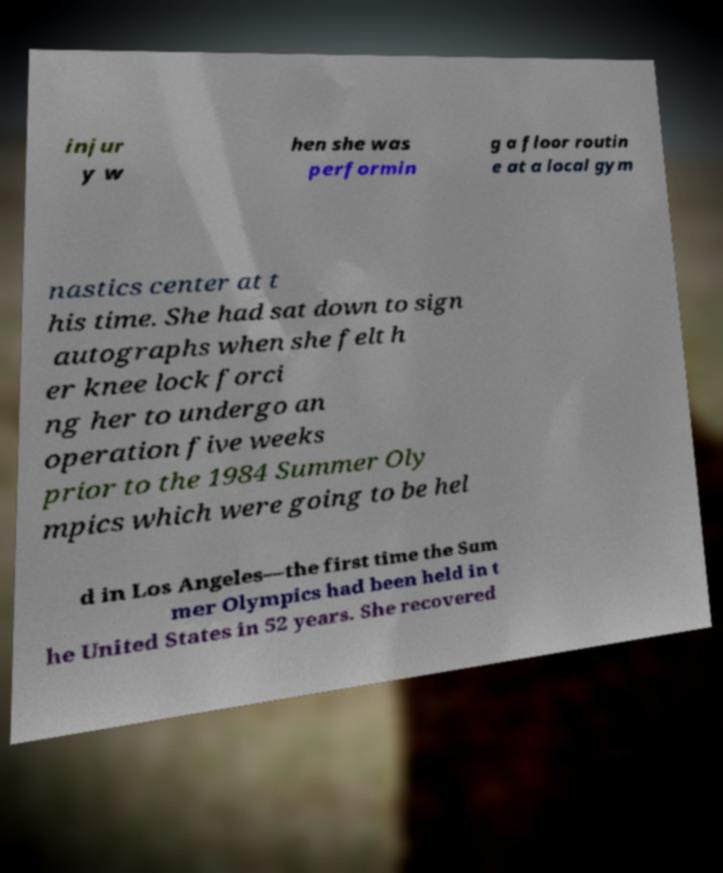There's text embedded in this image that I need extracted. Can you transcribe it verbatim? injur y w hen she was performin g a floor routin e at a local gym nastics center at t his time. She had sat down to sign autographs when she felt h er knee lock forci ng her to undergo an operation five weeks prior to the 1984 Summer Oly mpics which were going to be hel d in Los Angeles—the first time the Sum mer Olympics had been held in t he United States in 52 years. She recovered 